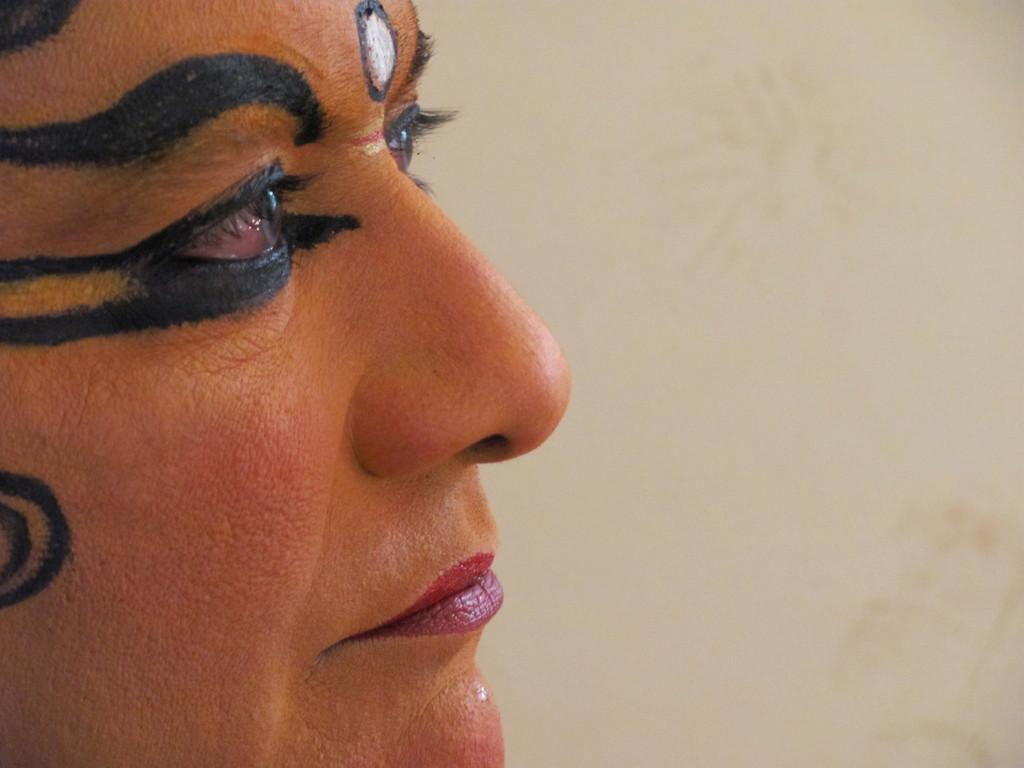What is the main subject of the image? The main subject of the image is a person's face. Can you describe the appearance of the person's face in the image? The person's face has full makeup. What type of turkey is being served for Thanksgiving in the image? There is no turkey or Thanksgiving celebration depicted in the image; it features a person's face with full makeup. Can you tell me if the person in the image has received approval for a project? The image does not provide any information about the person's approval status for a project. 